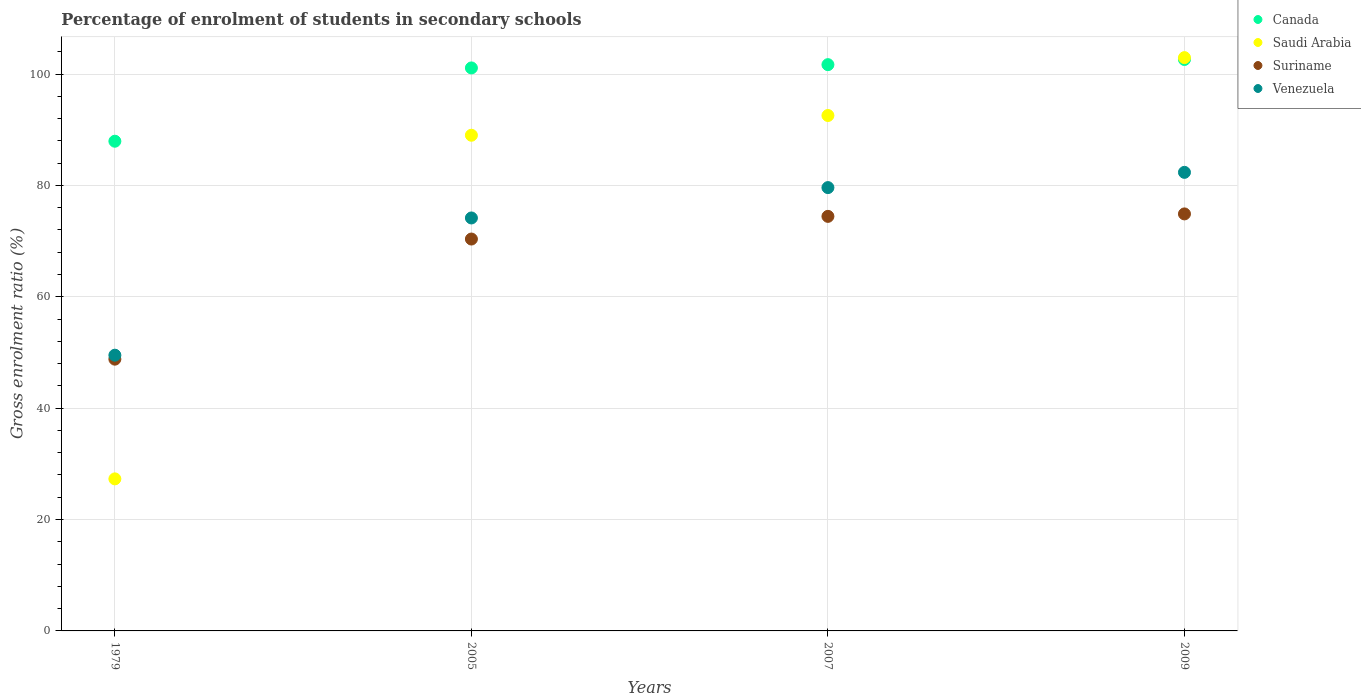How many different coloured dotlines are there?
Your answer should be very brief. 4. What is the percentage of students enrolled in secondary schools in Suriname in 1979?
Provide a short and direct response. 48.8. Across all years, what is the maximum percentage of students enrolled in secondary schools in Venezuela?
Your response must be concise. 82.34. Across all years, what is the minimum percentage of students enrolled in secondary schools in Suriname?
Make the answer very short. 48.8. In which year was the percentage of students enrolled in secondary schools in Suriname minimum?
Give a very brief answer. 1979. What is the total percentage of students enrolled in secondary schools in Saudi Arabia in the graph?
Provide a succinct answer. 311.8. What is the difference between the percentage of students enrolled in secondary schools in Saudi Arabia in 2005 and that in 2009?
Ensure brevity in your answer.  -13.94. What is the difference between the percentage of students enrolled in secondary schools in Venezuela in 2005 and the percentage of students enrolled in secondary schools in Suriname in 2007?
Keep it short and to the point. -0.29. What is the average percentage of students enrolled in secondary schools in Suriname per year?
Your answer should be compact. 67.12. In the year 2005, what is the difference between the percentage of students enrolled in secondary schools in Venezuela and percentage of students enrolled in secondary schools in Saudi Arabia?
Provide a short and direct response. -14.85. In how many years, is the percentage of students enrolled in secondary schools in Saudi Arabia greater than 8 %?
Your response must be concise. 4. What is the ratio of the percentage of students enrolled in secondary schools in Canada in 2005 to that in 2007?
Your answer should be compact. 0.99. Is the percentage of students enrolled in secondary schools in Saudi Arabia in 2005 less than that in 2007?
Offer a very short reply. Yes. What is the difference between the highest and the second highest percentage of students enrolled in secondary schools in Venezuela?
Your answer should be compact. 2.74. What is the difference between the highest and the lowest percentage of students enrolled in secondary schools in Venezuela?
Provide a succinct answer. 32.83. In how many years, is the percentage of students enrolled in secondary schools in Saudi Arabia greater than the average percentage of students enrolled in secondary schools in Saudi Arabia taken over all years?
Give a very brief answer. 3. Is the sum of the percentage of students enrolled in secondary schools in Suriname in 2005 and 2009 greater than the maximum percentage of students enrolled in secondary schools in Canada across all years?
Your response must be concise. Yes. Is it the case that in every year, the sum of the percentage of students enrolled in secondary schools in Canada and percentage of students enrolled in secondary schools in Venezuela  is greater than the sum of percentage of students enrolled in secondary schools in Saudi Arabia and percentage of students enrolled in secondary schools in Suriname?
Make the answer very short. No. Does the percentage of students enrolled in secondary schools in Saudi Arabia monotonically increase over the years?
Your answer should be compact. Yes. Is the percentage of students enrolled in secondary schools in Suriname strictly less than the percentage of students enrolled in secondary schools in Venezuela over the years?
Give a very brief answer. Yes. How many dotlines are there?
Your answer should be compact. 4. How many years are there in the graph?
Your answer should be very brief. 4. Where does the legend appear in the graph?
Give a very brief answer. Top right. How many legend labels are there?
Your answer should be very brief. 4. How are the legend labels stacked?
Provide a succinct answer. Vertical. What is the title of the graph?
Offer a very short reply. Percentage of enrolment of students in secondary schools. Does "Ireland" appear as one of the legend labels in the graph?
Give a very brief answer. No. What is the Gross enrolment ratio (%) of Canada in 1979?
Your answer should be compact. 87.93. What is the Gross enrolment ratio (%) of Saudi Arabia in 1979?
Provide a succinct answer. 27.3. What is the Gross enrolment ratio (%) of Suriname in 1979?
Give a very brief answer. 48.8. What is the Gross enrolment ratio (%) of Venezuela in 1979?
Provide a short and direct response. 49.51. What is the Gross enrolment ratio (%) of Canada in 2005?
Your answer should be compact. 101.09. What is the Gross enrolment ratio (%) in Saudi Arabia in 2005?
Your response must be concise. 89.01. What is the Gross enrolment ratio (%) in Suriname in 2005?
Provide a short and direct response. 70.37. What is the Gross enrolment ratio (%) of Venezuela in 2005?
Your answer should be very brief. 74.15. What is the Gross enrolment ratio (%) of Canada in 2007?
Provide a short and direct response. 101.68. What is the Gross enrolment ratio (%) in Saudi Arabia in 2007?
Your answer should be compact. 92.55. What is the Gross enrolment ratio (%) in Suriname in 2007?
Your response must be concise. 74.44. What is the Gross enrolment ratio (%) in Venezuela in 2007?
Your response must be concise. 79.61. What is the Gross enrolment ratio (%) of Canada in 2009?
Offer a terse response. 102.61. What is the Gross enrolment ratio (%) of Saudi Arabia in 2009?
Your answer should be very brief. 102.94. What is the Gross enrolment ratio (%) in Suriname in 2009?
Offer a terse response. 74.88. What is the Gross enrolment ratio (%) in Venezuela in 2009?
Offer a terse response. 82.34. Across all years, what is the maximum Gross enrolment ratio (%) of Canada?
Your answer should be very brief. 102.61. Across all years, what is the maximum Gross enrolment ratio (%) in Saudi Arabia?
Give a very brief answer. 102.94. Across all years, what is the maximum Gross enrolment ratio (%) in Suriname?
Your response must be concise. 74.88. Across all years, what is the maximum Gross enrolment ratio (%) of Venezuela?
Your answer should be very brief. 82.34. Across all years, what is the minimum Gross enrolment ratio (%) in Canada?
Give a very brief answer. 87.93. Across all years, what is the minimum Gross enrolment ratio (%) of Saudi Arabia?
Your answer should be very brief. 27.3. Across all years, what is the minimum Gross enrolment ratio (%) of Suriname?
Your answer should be very brief. 48.8. Across all years, what is the minimum Gross enrolment ratio (%) in Venezuela?
Provide a short and direct response. 49.51. What is the total Gross enrolment ratio (%) of Canada in the graph?
Keep it short and to the point. 393.32. What is the total Gross enrolment ratio (%) in Saudi Arabia in the graph?
Ensure brevity in your answer.  311.8. What is the total Gross enrolment ratio (%) in Suriname in the graph?
Your answer should be very brief. 268.49. What is the total Gross enrolment ratio (%) in Venezuela in the graph?
Provide a short and direct response. 285.61. What is the difference between the Gross enrolment ratio (%) of Canada in 1979 and that in 2005?
Make the answer very short. -13.16. What is the difference between the Gross enrolment ratio (%) of Saudi Arabia in 1979 and that in 2005?
Provide a short and direct response. -61.7. What is the difference between the Gross enrolment ratio (%) of Suriname in 1979 and that in 2005?
Provide a succinct answer. -21.57. What is the difference between the Gross enrolment ratio (%) of Venezuela in 1979 and that in 2005?
Ensure brevity in your answer.  -24.64. What is the difference between the Gross enrolment ratio (%) in Canada in 1979 and that in 2007?
Make the answer very short. -13.75. What is the difference between the Gross enrolment ratio (%) in Saudi Arabia in 1979 and that in 2007?
Your answer should be very brief. -65.25. What is the difference between the Gross enrolment ratio (%) of Suriname in 1979 and that in 2007?
Offer a very short reply. -25.64. What is the difference between the Gross enrolment ratio (%) of Venezuela in 1979 and that in 2007?
Ensure brevity in your answer.  -30.1. What is the difference between the Gross enrolment ratio (%) of Canada in 1979 and that in 2009?
Give a very brief answer. -14.68. What is the difference between the Gross enrolment ratio (%) of Saudi Arabia in 1979 and that in 2009?
Make the answer very short. -75.64. What is the difference between the Gross enrolment ratio (%) in Suriname in 1979 and that in 2009?
Your answer should be compact. -26.08. What is the difference between the Gross enrolment ratio (%) of Venezuela in 1979 and that in 2009?
Provide a succinct answer. -32.83. What is the difference between the Gross enrolment ratio (%) of Canada in 2005 and that in 2007?
Offer a terse response. -0.59. What is the difference between the Gross enrolment ratio (%) in Saudi Arabia in 2005 and that in 2007?
Your response must be concise. -3.54. What is the difference between the Gross enrolment ratio (%) of Suriname in 2005 and that in 2007?
Make the answer very short. -4.07. What is the difference between the Gross enrolment ratio (%) of Venezuela in 2005 and that in 2007?
Your response must be concise. -5.45. What is the difference between the Gross enrolment ratio (%) in Canada in 2005 and that in 2009?
Provide a short and direct response. -1.52. What is the difference between the Gross enrolment ratio (%) in Saudi Arabia in 2005 and that in 2009?
Your answer should be compact. -13.94. What is the difference between the Gross enrolment ratio (%) in Suriname in 2005 and that in 2009?
Give a very brief answer. -4.51. What is the difference between the Gross enrolment ratio (%) of Venezuela in 2005 and that in 2009?
Keep it short and to the point. -8.19. What is the difference between the Gross enrolment ratio (%) in Canada in 2007 and that in 2009?
Offer a terse response. -0.93. What is the difference between the Gross enrolment ratio (%) in Saudi Arabia in 2007 and that in 2009?
Your answer should be very brief. -10.39. What is the difference between the Gross enrolment ratio (%) of Suriname in 2007 and that in 2009?
Your response must be concise. -0.44. What is the difference between the Gross enrolment ratio (%) of Venezuela in 2007 and that in 2009?
Give a very brief answer. -2.74. What is the difference between the Gross enrolment ratio (%) of Canada in 1979 and the Gross enrolment ratio (%) of Saudi Arabia in 2005?
Your answer should be very brief. -1.07. What is the difference between the Gross enrolment ratio (%) of Canada in 1979 and the Gross enrolment ratio (%) of Suriname in 2005?
Provide a succinct answer. 17.56. What is the difference between the Gross enrolment ratio (%) in Canada in 1979 and the Gross enrolment ratio (%) in Venezuela in 2005?
Offer a very short reply. 13.78. What is the difference between the Gross enrolment ratio (%) of Saudi Arabia in 1979 and the Gross enrolment ratio (%) of Suriname in 2005?
Keep it short and to the point. -43.07. What is the difference between the Gross enrolment ratio (%) in Saudi Arabia in 1979 and the Gross enrolment ratio (%) in Venezuela in 2005?
Offer a terse response. -46.85. What is the difference between the Gross enrolment ratio (%) in Suriname in 1979 and the Gross enrolment ratio (%) in Venezuela in 2005?
Your answer should be compact. -25.36. What is the difference between the Gross enrolment ratio (%) in Canada in 1979 and the Gross enrolment ratio (%) in Saudi Arabia in 2007?
Offer a terse response. -4.62. What is the difference between the Gross enrolment ratio (%) in Canada in 1979 and the Gross enrolment ratio (%) in Suriname in 2007?
Your response must be concise. 13.49. What is the difference between the Gross enrolment ratio (%) of Canada in 1979 and the Gross enrolment ratio (%) of Venezuela in 2007?
Your answer should be compact. 8.33. What is the difference between the Gross enrolment ratio (%) in Saudi Arabia in 1979 and the Gross enrolment ratio (%) in Suriname in 2007?
Offer a terse response. -47.14. What is the difference between the Gross enrolment ratio (%) of Saudi Arabia in 1979 and the Gross enrolment ratio (%) of Venezuela in 2007?
Provide a succinct answer. -52.3. What is the difference between the Gross enrolment ratio (%) in Suriname in 1979 and the Gross enrolment ratio (%) in Venezuela in 2007?
Provide a succinct answer. -30.81. What is the difference between the Gross enrolment ratio (%) in Canada in 1979 and the Gross enrolment ratio (%) in Saudi Arabia in 2009?
Offer a terse response. -15.01. What is the difference between the Gross enrolment ratio (%) of Canada in 1979 and the Gross enrolment ratio (%) of Suriname in 2009?
Offer a very short reply. 13.05. What is the difference between the Gross enrolment ratio (%) in Canada in 1979 and the Gross enrolment ratio (%) in Venezuela in 2009?
Offer a very short reply. 5.59. What is the difference between the Gross enrolment ratio (%) in Saudi Arabia in 1979 and the Gross enrolment ratio (%) in Suriname in 2009?
Make the answer very short. -47.58. What is the difference between the Gross enrolment ratio (%) in Saudi Arabia in 1979 and the Gross enrolment ratio (%) in Venezuela in 2009?
Your answer should be very brief. -55.04. What is the difference between the Gross enrolment ratio (%) of Suriname in 1979 and the Gross enrolment ratio (%) of Venezuela in 2009?
Your response must be concise. -33.54. What is the difference between the Gross enrolment ratio (%) in Canada in 2005 and the Gross enrolment ratio (%) in Saudi Arabia in 2007?
Keep it short and to the point. 8.54. What is the difference between the Gross enrolment ratio (%) of Canada in 2005 and the Gross enrolment ratio (%) of Suriname in 2007?
Your answer should be very brief. 26.65. What is the difference between the Gross enrolment ratio (%) in Canada in 2005 and the Gross enrolment ratio (%) in Venezuela in 2007?
Ensure brevity in your answer.  21.49. What is the difference between the Gross enrolment ratio (%) in Saudi Arabia in 2005 and the Gross enrolment ratio (%) in Suriname in 2007?
Offer a terse response. 14.57. What is the difference between the Gross enrolment ratio (%) of Saudi Arabia in 2005 and the Gross enrolment ratio (%) of Venezuela in 2007?
Keep it short and to the point. 9.4. What is the difference between the Gross enrolment ratio (%) of Suriname in 2005 and the Gross enrolment ratio (%) of Venezuela in 2007?
Your response must be concise. -9.24. What is the difference between the Gross enrolment ratio (%) in Canada in 2005 and the Gross enrolment ratio (%) in Saudi Arabia in 2009?
Your response must be concise. -1.85. What is the difference between the Gross enrolment ratio (%) in Canada in 2005 and the Gross enrolment ratio (%) in Suriname in 2009?
Your answer should be compact. 26.21. What is the difference between the Gross enrolment ratio (%) of Canada in 2005 and the Gross enrolment ratio (%) of Venezuela in 2009?
Give a very brief answer. 18.75. What is the difference between the Gross enrolment ratio (%) in Saudi Arabia in 2005 and the Gross enrolment ratio (%) in Suriname in 2009?
Offer a very short reply. 14.13. What is the difference between the Gross enrolment ratio (%) of Saudi Arabia in 2005 and the Gross enrolment ratio (%) of Venezuela in 2009?
Offer a very short reply. 6.66. What is the difference between the Gross enrolment ratio (%) in Suriname in 2005 and the Gross enrolment ratio (%) in Venezuela in 2009?
Offer a very short reply. -11.97. What is the difference between the Gross enrolment ratio (%) of Canada in 2007 and the Gross enrolment ratio (%) of Saudi Arabia in 2009?
Your answer should be very brief. -1.26. What is the difference between the Gross enrolment ratio (%) in Canada in 2007 and the Gross enrolment ratio (%) in Suriname in 2009?
Your response must be concise. 26.8. What is the difference between the Gross enrolment ratio (%) in Canada in 2007 and the Gross enrolment ratio (%) in Venezuela in 2009?
Give a very brief answer. 19.34. What is the difference between the Gross enrolment ratio (%) in Saudi Arabia in 2007 and the Gross enrolment ratio (%) in Suriname in 2009?
Offer a terse response. 17.67. What is the difference between the Gross enrolment ratio (%) in Saudi Arabia in 2007 and the Gross enrolment ratio (%) in Venezuela in 2009?
Your answer should be compact. 10.21. What is the difference between the Gross enrolment ratio (%) in Suriname in 2007 and the Gross enrolment ratio (%) in Venezuela in 2009?
Your answer should be compact. -7.9. What is the average Gross enrolment ratio (%) in Canada per year?
Your answer should be very brief. 98.33. What is the average Gross enrolment ratio (%) in Saudi Arabia per year?
Make the answer very short. 77.95. What is the average Gross enrolment ratio (%) of Suriname per year?
Make the answer very short. 67.12. What is the average Gross enrolment ratio (%) of Venezuela per year?
Your answer should be compact. 71.4. In the year 1979, what is the difference between the Gross enrolment ratio (%) in Canada and Gross enrolment ratio (%) in Saudi Arabia?
Your response must be concise. 60.63. In the year 1979, what is the difference between the Gross enrolment ratio (%) in Canada and Gross enrolment ratio (%) in Suriname?
Provide a short and direct response. 39.13. In the year 1979, what is the difference between the Gross enrolment ratio (%) of Canada and Gross enrolment ratio (%) of Venezuela?
Your response must be concise. 38.42. In the year 1979, what is the difference between the Gross enrolment ratio (%) in Saudi Arabia and Gross enrolment ratio (%) in Suriname?
Provide a succinct answer. -21.5. In the year 1979, what is the difference between the Gross enrolment ratio (%) in Saudi Arabia and Gross enrolment ratio (%) in Venezuela?
Provide a short and direct response. -22.21. In the year 1979, what is the difference between the Gross enrolment ratio (%) in Suriname and Gross enrolment ratio (%) in Venezuela?
Your answer should be compact. -0.71. In the year 2005, what is the difference between the Gross enrolment ratio (%) in Canada and Gross enrolment ratio (%) in Saudi Arabia?
Make the answer very short. 12.09. In the year 2005, what is the difference between the Gross enrolment ratio (%) in Canada and Gross enrolment ratio (%) in Suriname?
Offer a very short reply. 30.72. In the year 2005, what is the difference between the Gross enrolment ratio (%) of Canada and Gross enrolment ratio (%) of Venezuela?
Make the answer very short. 26.94. In the year 2005, what is the difference between the Gross enrolment ratio (%) in Saudi Arabia and Gross enrolment ratio (%) in Suriname?
Offer a terse response. 18.64. In the year 2005, what is the difference between the Gross enrolment ratio (%) of Saudi Arabia and Gross enrolment ratio (%) of Venezuela?
Give a very brief answer. 14.85. In the year 2005, what is the difference between the Gross enrolment ratio (%) in Suriname and Gross enrolment ratio (%) in Venezuela?
Your answer should be compact. -3.78. In the year 2007, what is the difference between the Gross enrolment ratio (%) in Canada and Gross enrolment ratio (%) in Saudi Arabia?
Give a very brief answer. 9.13. In the year 2007, what is the difference between the Gross enrolment ratio (%) of Canada and Gross enrolment ratio (%) of Suriname?
Provide a succinct answer. 27.24. In the year 2007, what is the difference between the Gross enrolment ratio (%) of Canada and Gross enrolment ratio (%) of Venezuela?
Your response must be concise. 22.08. In the year 2007, what is the difference between the Gross enrolment ratio (%) in Saudi Arabia and Gross enrolment ratio (%) in Suriname?
Your answer should be very brief. 18.11. In the year 2007, what is the difference between the Gross enrolment ratio (%) of Saudi Arabia and Gross enrolment ratio (%) of Venezuela?
Give a very brief answer. 12.95. In the year 2007, what is the difference between the Gross enrolment ratio (%) of Suriname and Gross enrolment ratio (%) of Venezuela?
Offer a terse response. -5.17. In the year 2009, what is the difference between the Gross enrolment ratio (%) of Canada and Gross enrolment ratio (%) of Saudi Arabia?
Give a very brief answer. -0.33. In the year 2009, what is the difference between the Gross enrolment ratio (%) in Canada and Gross enrolment ratio (%) in Suriname?
Your answer should be very brief. 27.73. In the year 2009, what is the difference between the Gross enrolment ratio (%) in Canada and Gross enrolment ratio (%) in Venezuela?
Ensure brevity in your answer.  20.27. In the year 2009, what is the difference between the Gross enrolment ratio (%) of Saudi Arabia and Gross enrolment ratio (%) of Suriname?
Provide a short and direct response. 28.06. In the year 2009, what is the difference between the Gross enrolment ratio (%) of Saudi Arabia and Gross enrolment ratio (%) of Venezuela?
Your response must be concise. 20.6. In the year 2009, what is the difference between the Gross enrolment ratio (%) of Suriname and Gross enrolment ratio (%) of Venezuela?
Offer a very short reply. -7.46. What is the ratio of the Gross enrolment ratio (%) of Canada in 1979 to that in 2005?
Make the answer very short. 0.87. What is the ratio of the Gross enrolment ratio (%) in Saudi Arabia in 1979 to that in 2005?
Provide a short and direct response. 0.31. What is the ratio of the Gross enrolment ratio (%) in Suriname in 1979 to that in 2005?
Ensure brevity in your answer.  0.69. What is the ratio of the Gross enrolment ratio (%) in Venezuela in 1979 to that in 2005?
Give a very brief answer. 0.67. What is the ratio of the Gross enrolment ratio (%) in Canada in 1979 to that in 2007?
Your answer should be compact. 0.86. What is the ratio of the Gross enrolment ratio (%) in Saudi Arabia in 1979 to that in 2007?
Make the answer very short. 0.29. What is the ratio of the Gross enrolment ratio (%) in Suriname in 1979 to that in 2007?
Your answer should be very brief. 0.66. What is the ratio of the Gross enrolment ratio (%) in Venezuela in 1979 to that in 2007?
Offer a terse response. 0.62. What is the ratio of the Gross enrolment ratio (%) of Canada in 1979 to that in 2009?
Offer a very short reply. 0.86. What is the ratio of the Gross enrolment ratio (%) in Saudi Arabia in 1979 to that in 2009?
Make the answer very short. 0.27. What is the ratio of the Gross enrolment ratio (%) of Suriname in 1979 to that in 2009?
Offer a very short reply. 0.65. What is the ratio of the Gross enrolment ratio (%) in Venezuela in 1979 to that in 2009?
Your answer should be compact. 0.6. What is the ratio of the Gross enrolment ratio (%) of Canada in 2005 to that in 2007?
Your response must be concise. 0.99. What is the ratio of the Gross enrolment ratio (%) of Saudi Arabia in 2005 to that in 2007?
Your answer should be very brief. 0.96. What is the ratio of the Gross enrolment ratio (%) in Suriname in 2005 to that in 2007?
Your answer should be very brief. 0.95. What is the ratio of the Gross enrolment ratio (%) in Venezuela in 2005 to that in 2007?
Your answer should be compact. 0.93. What is the ratio of the Gross enrolment ratio (%) of Canada in 2005 to that in 2009?
Your answer should be compact. 0.99. What is the ratio of the Gross enrolment ratio (%) in Saudi Arabia in 2005 to that in 2009?
Give a very brief answer. 0.86. What is the ratio of the Gross enrolment ratio (%) in Suriname in 2005 to that in 2009?
Keep it short and to the point. 0.94. What is the ratio of the Gross enrolment ratio (%) of Venezuela in 2005 to that in 2009?
Keep it short and to the point. 0.9. What is the ratio of the Gross enrolment ratio (%) of Saudi Arabia in 2007 to that in 2009?
Provide a succinct answer. 0.9. What is the ratio of the Gross enrolment ratio (%) in Venezuela in 2007 to that in 2009?
Your answer should be compact. 0.97. What is the difference between the highest and the second highest Gross enrolment ratio (%) in Canada?
Offer a terse response. 0.93. What is the difference between the highest and the second highest Gross enrolment ratio (%) of Saudi Arabia?
Keep it short and to the point. 10.39. What is the difference between the highest and the second highest Gross enrolment ratio (%) in Suriname?
Offer a very short reply. 0.44. What is the difference between the highest and the second highest Gross enrolment ratio (%) of Venezuela?
Provide a short and direct response. 2.74. What is the difference between the highest and the lowest Gross enrolment ratio (%) of Canada?
Provide a short and direct response. 14.68. What is the difference between the highest and the lowest Gross enrolment ratio (%) of Saudi Arabia?
Keep it short and to the point. 75.64. What is the difference between the highest and the lowest Gross enrolment ratio (%) in Suriname?
Give a very brief answer. 26.08. What is the difference between the highest and the lowest Gross enrolment ratio (%) in Venezuela?
Ensure brevity in your answer.  32.83. 